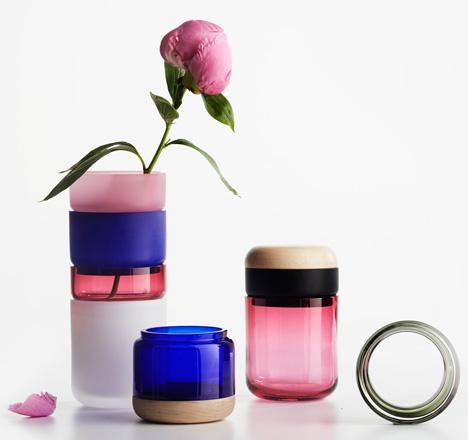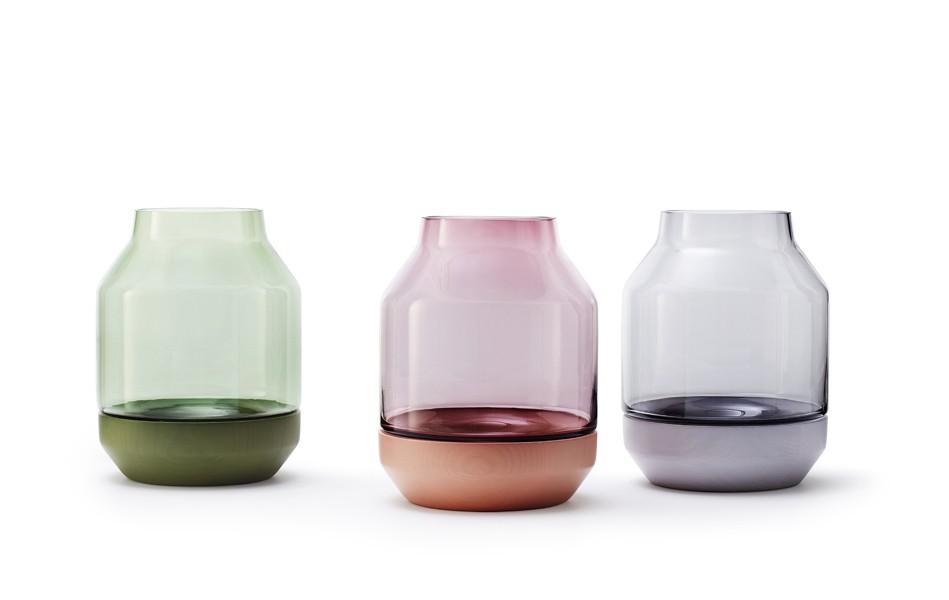The first image is the image on the left, the second image is the image on the right. Analyze the images presented: Is the assertion "All photos have exactly three vases or jars positioned in close proximity to each other." valid? Answer yes or no. Yes. 